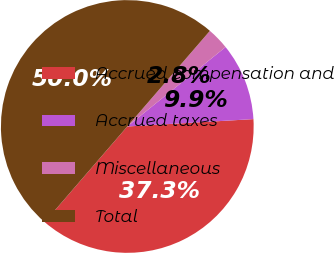Convert chart to OTSL. <chart><loc_0><loc_0><loc_500><loc_500><pie_chart><fcel>Accrued compensation and<fcel>Accrued taxes<fcel>Miscellaneous<fcel>Total<nl><fcel>37.26%<fcel>9.89%<fcel>2.84%<fcel>50.0%<nl></chart> 